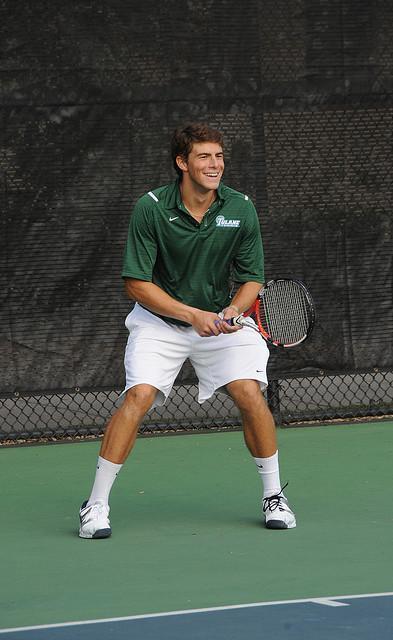How many people are pictured?
Give a very brief answer. 1. How many tennis rackets can you see?
Give a very brief answer. 1. How many zebras are there?
Give a very brief answer. 0. 